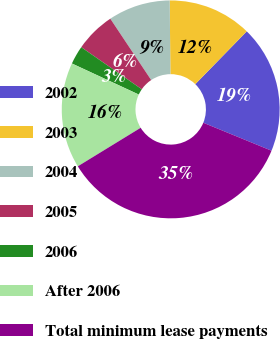Convert chart to OTSL. <chart><loc_0><loc_0><loc_500><loc_500><pie_chart><fcel>2002<fcel>2003<fcel>2004<fcel>2005<fcel>2006<fcel>After 2006<fcel>Total minimum lease payments<nl><fcel>18.9%<fcel>12.44%<fcel>9.21%<fcel>5.98%<fcel>2.75%<fcel>15.67%<fcel>35.06%<nl></chart> 